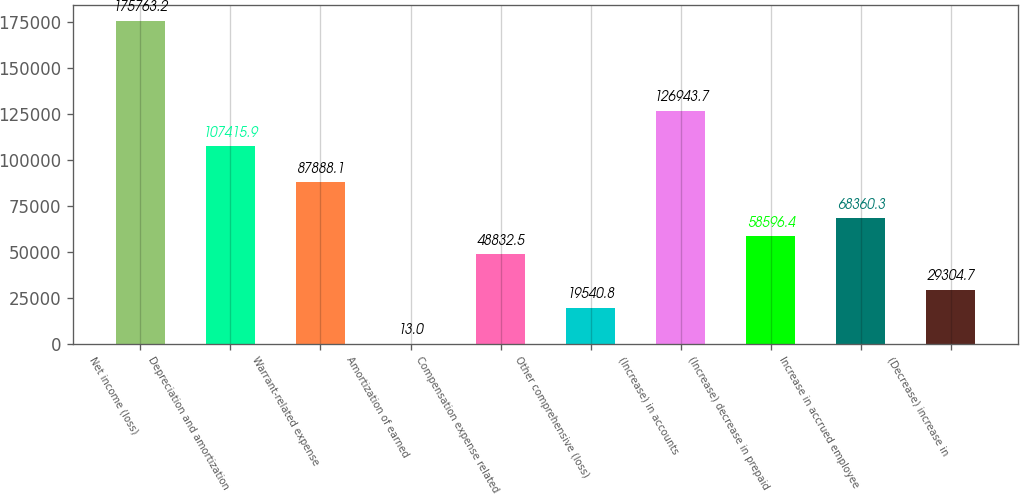Convert chart to OTSL. <chart><loc_0><loc_0><loc_500><loc_500><bar_chart><fcel>Net income (loss)<fcel>Depreciation and amortization<fcel>Warrant-related expense<fcel>Amortization of earned<fcel>Compensation expense related<fcel>Other comprehensive (loss)<fcel>(Increase) in accounts<fcel>(Increase) decrease in prepaid<fcel>Increase in accrued employee<fcel>(Decrease) increase in<nl><fcel>175763<fcel>107416<fcel>87888.1<fcel>13<fcel>48832.5<fcel>19540.8<fcel>126944<fcel>58596.4<fcel>68360.3<fcel>29304.7<nl></chart> 